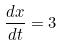<formula> <loc_0><loc_0><loc_500><loc_500>\frac { d x } { d t } = 3</formula> 